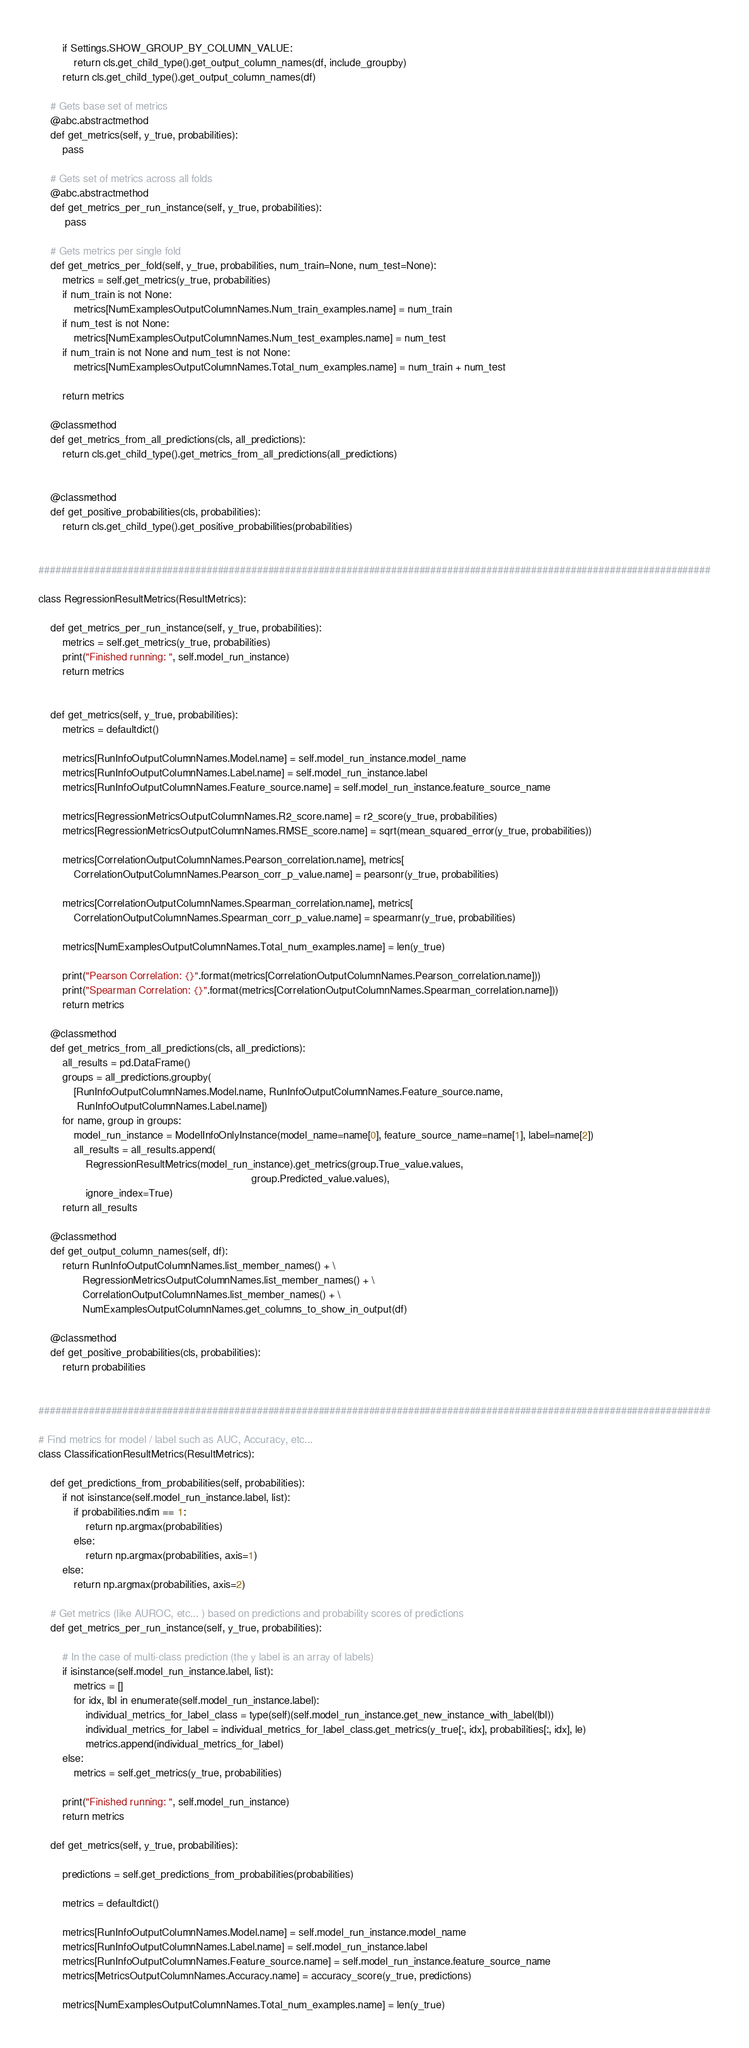Convert code to text. <code><loc_0><loc_0><loc_500><loc_500><_Python_>        if Settings.SHOW_GROUP_BY_COLUMN_VALUE:
            return cls.get_child_type().get_output_column_names(df, include_groupby)
        return cls.get_child_type().get_output_column_names(df)

    # Gets base set of metrics
    @abc.abstractmethod
    def get_metrics(self, y_true, probabilities):
        pass

    # Gets set of metrics across all folds
    @abc.abstractmethod
    def get_metrics_per_run_instance(self, y_true, probabilities):
         pass

    # Gets metrics per single fold
    def get_metrics_per_fold(self, y_true, probabilities, num_train=None, num_test=None):
        metrics = self.get_metrics(y_true, probabilities)
        if num_train is not None:
            metrics[NumExamplesOutputColumnNames.Num_train_examples.name] = num_train
        if num_test is not None:
            metrics[NumExamplesOutputColumnNames.Num_test_examples.name] = num_test
        if num_train is not None and num_test is not None:
            metrics[NumExamplesOutputColumnNames.Total_num_examples.name] = num_train + num_test

        return metrics

    @classmethod
    def get_metrics_from_all_predictions(cls, all_predictions):
        return cls.get_child_type().get_metrics_from_all_predictions(all_predictions)


    @classmethod
    def get_positive_probabilities(cls, probabilities):
        return cls.get_child_type().get_positive_probabilities(probabilities)


########################################################################################################################

class RegressionResultMetrics(ResultMetrics):

    def get_metrics_per_run_instance(self, y_true, probabilities):
        metrics = self.get_metrics(y_true, probabilities)
        print("Finished running: ", self.model_run_instance)
        return metrics


    def get_metrics(self, y_true, probabilities):
        metrics = defaultdict()

        metrics[RunInfoOutputColumnNames.Model.name] = self.model_run_instance.model_name
        metrics[RunInfoOutputColumnNames.Label.name] = self.model_run_instance.label
        metrics[RunInfoOutputColumnNames.Feature_source.name] = self.model_run_instance.feature_source_name

        metrics[RegressionMetricsOutputColumnNames.R2_score.name] = r2_score(y_true, probabilities)
        metrics[RegressionMetricsOutputColumnNames.RMSE_score.name] = sqrt(mean_squared_error(y_true, probabilities))

        metrics[CorrelationOutputColumnNames.Pearson_correlation.name], metrics[
            CorrelationOutputColumnNames.Pearson_corr_p_value.name] = pearsonr(y_true, probabilities)

        metrics[CorrelationOutputColumnNames.Spearman_correlation.name], metrics[
            CorrelationOutputColumnNames.Spearman_corr_p_value.name] = spearmanr(y_true, probabilities)

        metrics[NumExamplesOutputColumnNames.Total_num_examples.name] = len(y_true)

        print("Pearson Correlation: {}".format(metrics[CorrelationOutputColumnNames.Pearson_correlation.name]))
        print("Spearman Correlation: {}".format(metrics[CorrelationOutputColumnNames.Spearman_correlation.name]))
        return metrics

    @classmethod
    def get_metrics_from_all_predictions(cls, all_predictions):
        all_results = pd.DataFrame()
        groups = all_predictions.groupby(
            [RunInfoOutputColumnNames.Model.name, RunInfoOutputColumnNames.Feature_source.name,
             RunInfoOutputColumnNames.Label.name])
        for name, group in groups:
            model_run_instance = ModelInfoOnlyInstance(model_name=name[0], feature_source_name=name[1], label=name[2])
            all_results = all_results.append(
                RegressionResultMetrics(model_run_instance).get_metrics(group.True_value.values,
                                                                        group.Predicted_value.values),
                ignore_index=True)
        return all_results

    @classmethod
    def get_output_column_names(self, df):
        return RunInfoOutputColumnNames.list_member_names() + \
               RegressionMetricsOutputColumnNames.list_member_names() + \
               CorrelationOutputColumnNames.list_member_names() + \
               NumExamplesOutputColumnNames.get_columns_to_show_in_output(df)

    @classmethod
    def get_positive_probabilities(cls, probabilities):
        return probabilities


########################################################################################################################

# Find metrics for model / label such as AUC, Accuracy, etc...
class ClassificationResultMetrics(ResultMetrics):

    def get_predictions_from_probabilities(self, probabilities):
        if not isinstance(self.model_run_instance.label, list):
            if probabilities.ndim == 1:
                return np.argmax(probabilities)
            else:
                return np.argmax(probabilities, axis=1)
        else:
            return np.argmax(probabilities, axis=2)

    # Get metrics (like AUROC, etc... ) based on predictions and probability scores of predictions
    def get_metrics_per_run_instance(self, y_true, probabilities):

        # In the case of multi-class prediction (the y label is an array of labels)
        if isinstance(self.model_run_instance.label, list):
            metrics = []
            for idx, lbl in enumerate(self.model_run_instance.label):
                individual_metrics_for_label_class = type(self)(self.model_run_instance.get_new_instance_with_label(lbl))
                individual_metrics_for_label = individual_metrics_for_label_class.get_metrics(y_true[:, idx], probabilities[:, idx], le)
                metrics.append(individual_metrics_for_label)
        else:
            metrics = self.get_metrics(y_true, probabilities)

        print("Finished running: ", self.model_run_instance)
        return metrics

    def get_metrics(self, y_true, probabilities):

        predictions = self.get_predictions_from_probabilities(probabilities)

        metrics = defaultdict()

        metrics[RunInfoOutputColumnNames.Model.name] = self.model_run_instance.model_name
        metrics[RunInfoOutputColumnNames.Label.name] = self.model_run_instance.label
        metrics[RunInfoOutputColumnNames.Feature_source.name] = self.model_run_instance.feature_source_name
        metrics[MetricsOutputColumnNames.Accuracy.name] = accuracy_score(y_true, predictions)

        metrics[NumExamplesOutputColumnNames.Total_num_examples.name] = len(y_true)
</code> 